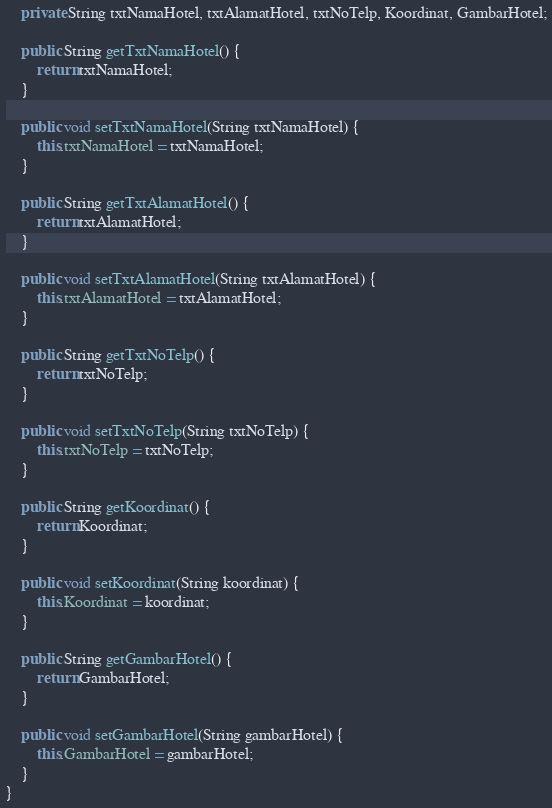Convert code to text. <code><loc_0><loc_0><loc_500><loc_500><_Java_>    private String txtNamaHotel, txtAlamatHotel, txtNoTelp, Koordinat, GambarHotel;

    public String getTxtNamaHotel() {
        return txtNamaHotel;
    }

    public void setTxtNamaHotel(String txtNamaHotel) {
        this.txtNamaHotel = txtNamaHotel;
    }

    public String getTxtAlamatHotel() {
        return txtAlamatHotel;
    }

    public void setTxtAlamatHotel(String txtAlamatHotel) {
        this.txtAlamatHotel = txtAlamatHotel;
    }

    public String getTxtNoTelp() {
        return txtNoTelp;
    }

    public void setTxtNoTelp(String txtNoTelp) {
        this.txtNoTelp = txtNoTelp;
    }

    public String getKoordinat() {
        return Koordinat;
    }

    public void setKoordinat(String koordinat) {
        this.Koordinat = koordinat;
    }

    public String getGambarHotel() {
        return GambarHotel;
    }

    public void setGambarHotel(String gambarHotel) {
        this.GambarHotel = gambarHotel;
    }
}
</code> 